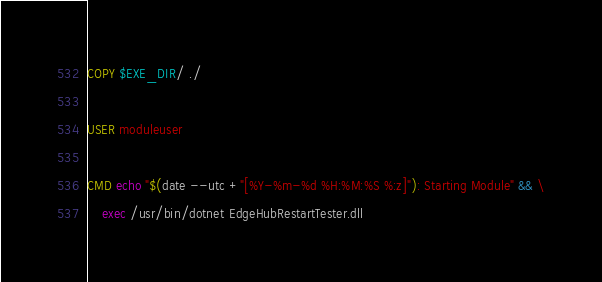Convert code to text. <code><loc_0><loc_0><loc_500><loc_500><_Dockerfile_>COPY $EXE_DIR/ ./

USER moduleuser

CMD echo "$(date --utc +"[%Y-%m-%d %H:%M:%S %:z]"): Starting Module" && \
    exec /usr/bin/dotnet EdgeHubRestartTester.dll
</code> 